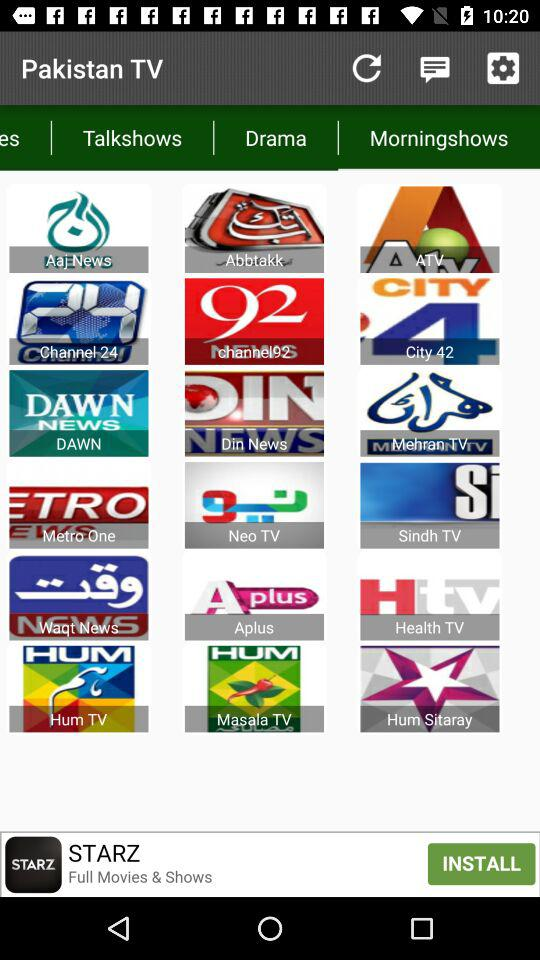Which tab is selected? The selected tab is "Morningshows". 